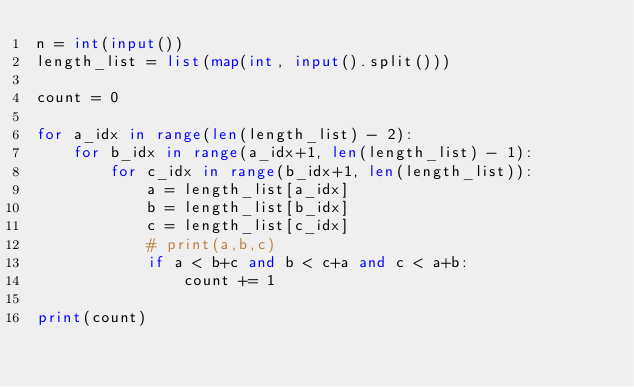<code> <loc_0><loc_0><loc_500><loc_500><_Python_>n = int(input())
length_list = list(map(int, input().split()))

count = 0

for a_idx in range(len(length_list) - 2):
    for b_idx in range(a_idx+1, len(length_list) - 1):
        for c_idx in range(b_idx+1, len(length_list)):
            a = length_list[a_idx]
            b = length_list[b_idx]
            c = length_list[c_idx]
            # print(a,b,c)
            if a < b+c and b < c+a and c < a+b:
                count += 1  

print(count)</code> 